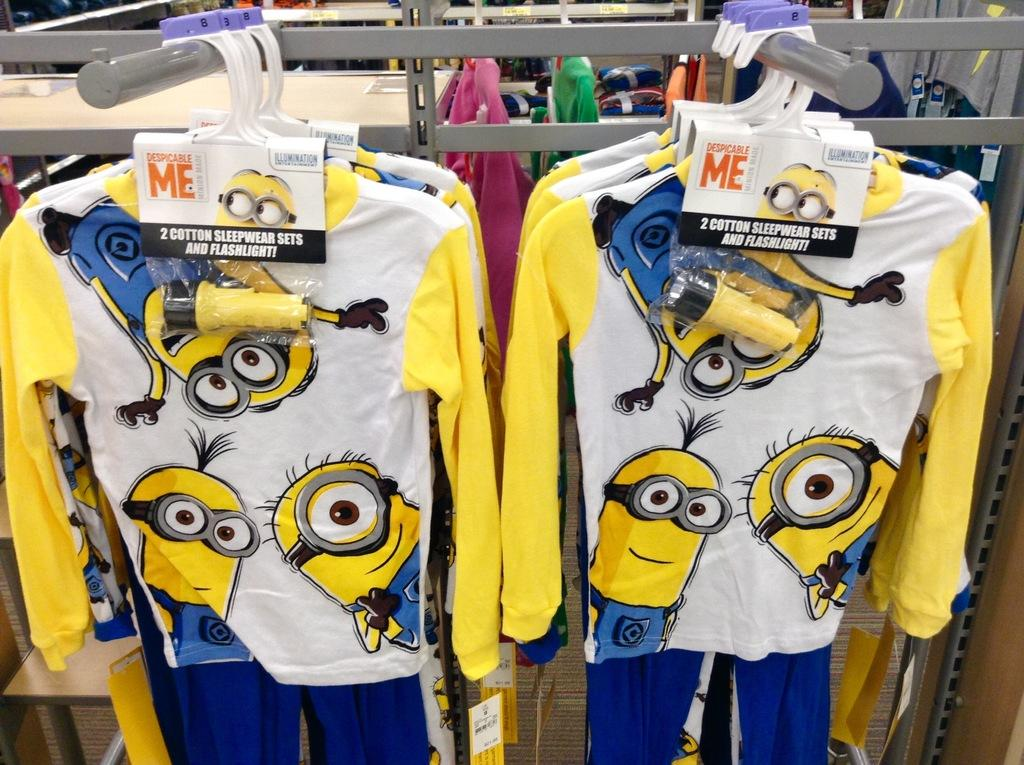<image>
Relay a brief, clear account of the picture shown. Despicable Me pajamas featuring minions on them are display 